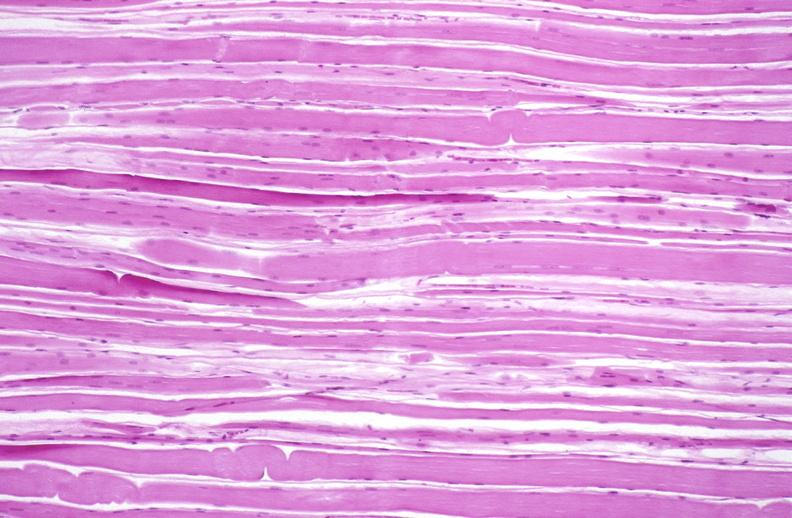what is present?
Answer the question using a single word or phrase. Soft tissue 